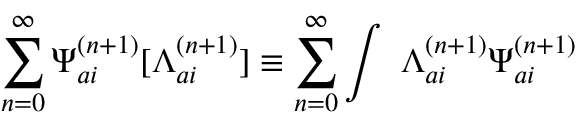Convert formula to latex. <formula><loc_0><loc_0><loc_500><loc_500>\sum _ { n = 0 } ^ { \infty } { \Psi } _ { a i } ^ { ( n + 1 ) } [ { \Lambda } _ { a i } ^ { ( n + 1 ) } ] \equiv \sum _ { n = 0 } ^ { \infty } \int \ { \Lambda } _ { a i } ^ { ( n + 1 ) } { \Psi } _ { a i } ^ { ( n + 1 ) }</formula> 